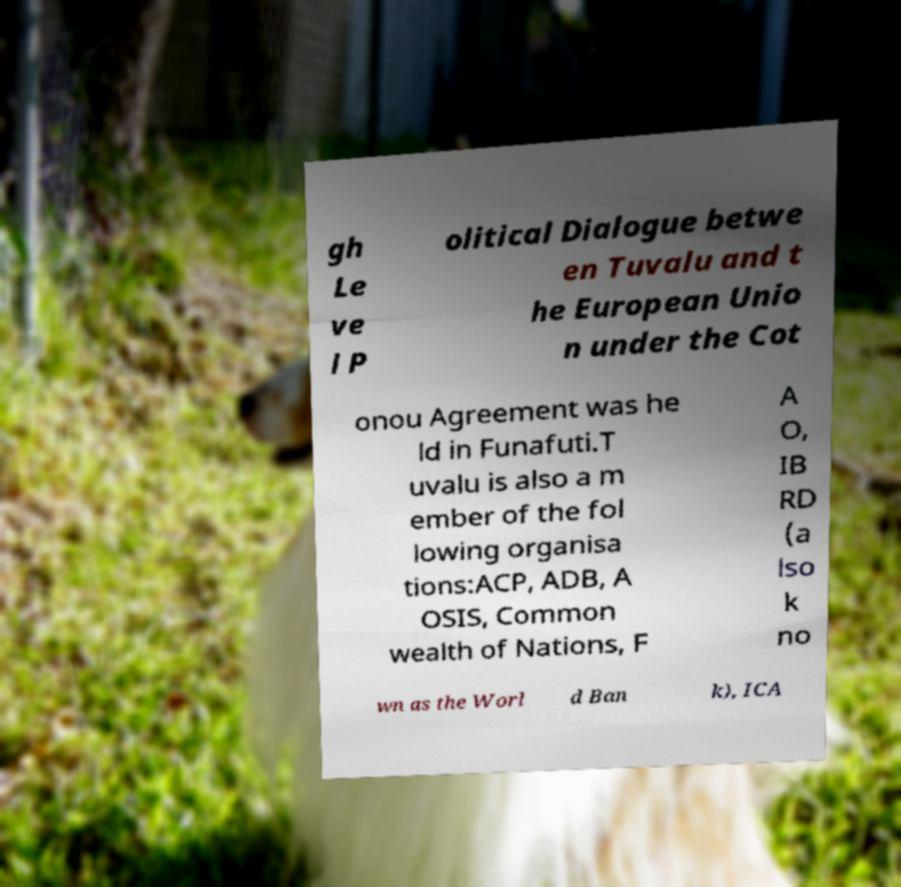What messages or text are displayed in this image? I need them in a readable, typed format. gh Le ve l P olitical Dialogue betwe en Tuvalu and t he European Unio n under the Cot onou Agreement was he ld in Funafuti.T uvalu is also a m ember of the fol lowing organisa tions:ACP, ADB, A OSIS, Common wealth of Nations, F A O, IB RD (a lso k no wn as the Worl d Ban k), ICA 